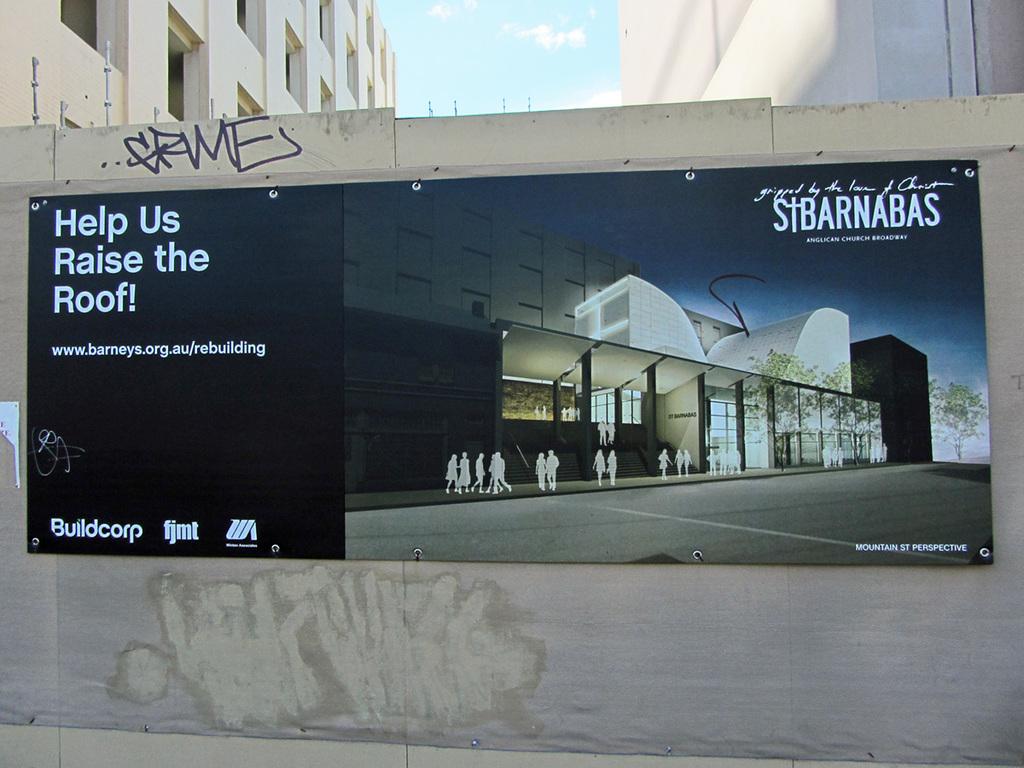What are they raising?
Provide a succinct answer. The roof. What is the website shown?
Your answer should be compact. Www.barneys.org.au/rebuilding. 